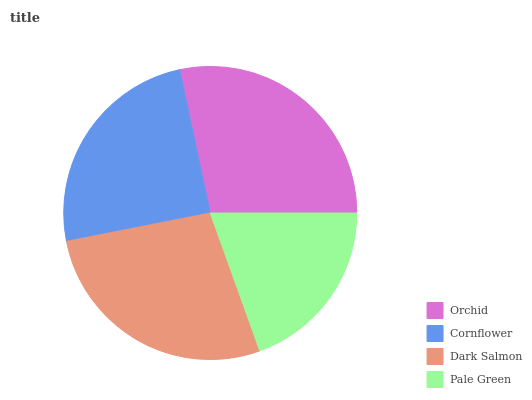Is Pale Green the minimum?
Answer yes or no. Yes. Is Orchid the maximum?
Answer yes or no. Yes. Is Cornflower the minimum?
Answer yes or no. No. Is Cornflower the maximum?
Answer yes or no. No. Is Orchid greater than Cornflower?
Answer yes or no. Yes. Is Cornflower less than Orchid?
Answer yes or no. Yes. Is Cornflower greater than Orchid?
Answer yes or no. No. Is Orchid less than Cornflower?
Answer yes or no. No. Is Dark Salmon the high median?
Answer yes or no. Yes. Is Cornflower the low median?
Answer yes or no. Yes. Is Cornflower the high median?
Answer yes or no. No. Is Orchid the low median?
Answer yes or no. No. 